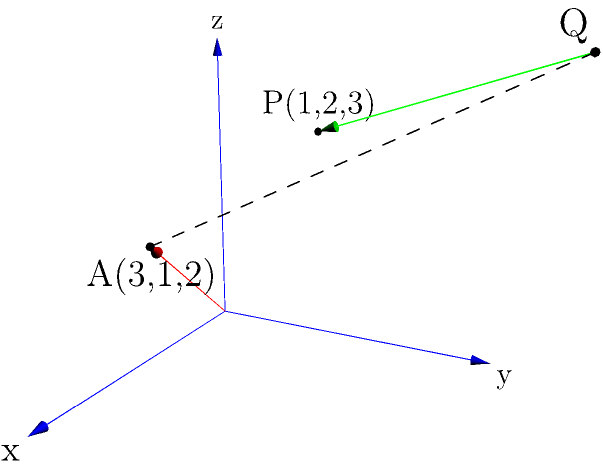Consider the point $P(1,2,3)$ and the line $L$ passing through the point $A(3,1,2)$ with direction vector $\vec{d} = \langle -1,2,1 \rangle$. Using vector methods, determine the shortest distance between point $P$ and line $L$. Express your answer in terms of the magnitude of the cross product of two vectors. To find the shortest distance between a point and a line in 3D space using vector methods, we can follow these steps:

1) First, we need to define a vector from point $A$ on the line to point $P$:
   $\vec{AP} = P - A = \langle 1-3, 2-1, 3-2 \rangle = \langle -2, 1, 1 \rangle$

2) The direction vector of the line is given: $\vec{d} = \langle -1, 2, 1 \rangle$

3) The shortest distance will be perpendicular to the line. This means it will be perpendicular to the direction vector $\vec{d}$. We can find this perpendicular vector by taking the cross product of $\vec{AP}$ and $\vec{d}$:

   $\vec{AP} \times \vec{d} = \begin{vmatrix} 
   \hat{i} & \hat{j} & \hat{k} \\
   -2 & 1 & 1 \\
   -1 & 2 & 1
   \end{vmatrix} = \langle 1-2, -1-(-2), -4-(-1) \rangle = \langle -1, 1, -3 \rangle$

4) The magnitude of this cross product gives us the area of the parallelogram formed by these vectors. This area is equal to the product of the magnitudes of $\vec{AP}$ and the shortest distance.

5) Therefore, the shortest distance is given by:

   $\text{distance} = \frac{|\vec{AP} \times \vec{d}|}{|\vec{d}|}$

6) We've already calculated $\vec{AP} \times \vec{d}$. Its magnitude is:
   $|\vec{AP} \times \vec{d}| = \sqrt{(-1)^2 + 1^2 + (-3)^2} = \sqrt{11}$

7) The magnitude of $\vec{d}$ is:
   $|\vec{d}| = \sqrt{(-1)^2 + 2^2 + 1^2} = \sqrt{6}$

8) Therefore, the shortest distance is:
   $\text{distance} = \frac{\sqrt{11}}{\sqrt{6}} = \frac{\sqrt{11}}{\sqrt{6}} \cdot \frac{\sqrt{6}}{\sqrt{6}} = \frac{\sqrt{66}}{6}$

This can be expressed as $\frac{|\vec{AP} \times \vec{d}|}{|\vec{d}|}$.
Answer: $\frac{|\vec{AP} \times \vec{d}|}{|\vec{d}|}$ 